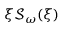<formula> <loc_0><loc_0><loc_500><loc_500>\xi \mathcal { S } _ { \omega } ( \xi )</formula> 